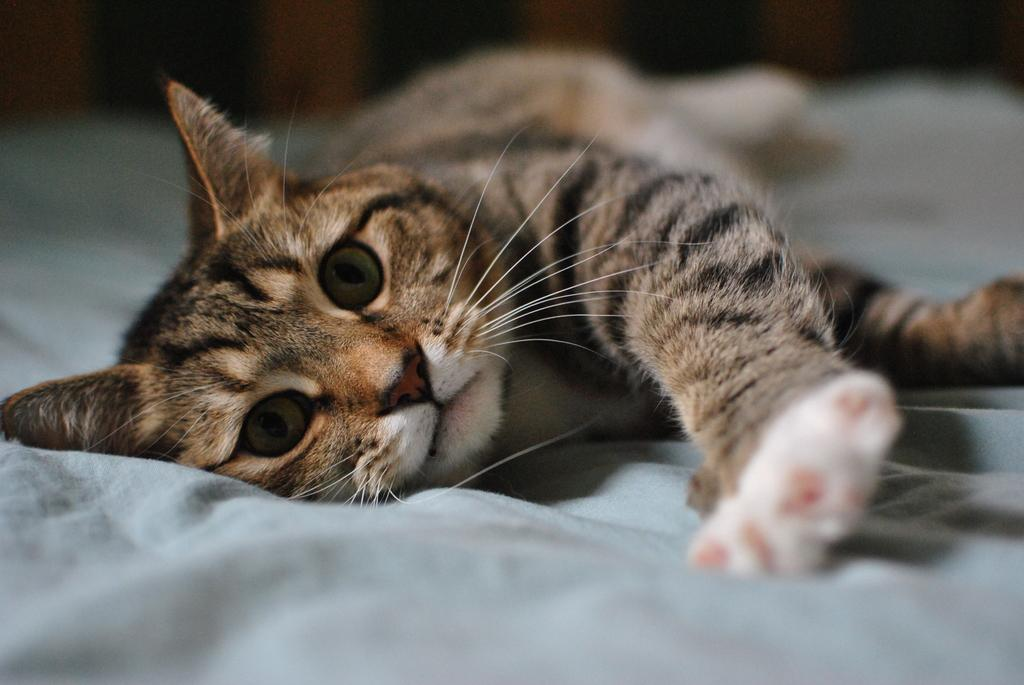What type of animal is in the image? There is a cat in the image. What is the cat doing in the image? The cat is lying down. What is the cat resting on in the image? The cat is on a cloth. How does the cat contribute to reducing pollution in the image? The image does not show the cat contributing to reducing pollution, as it is simply lying down on a cloth. 